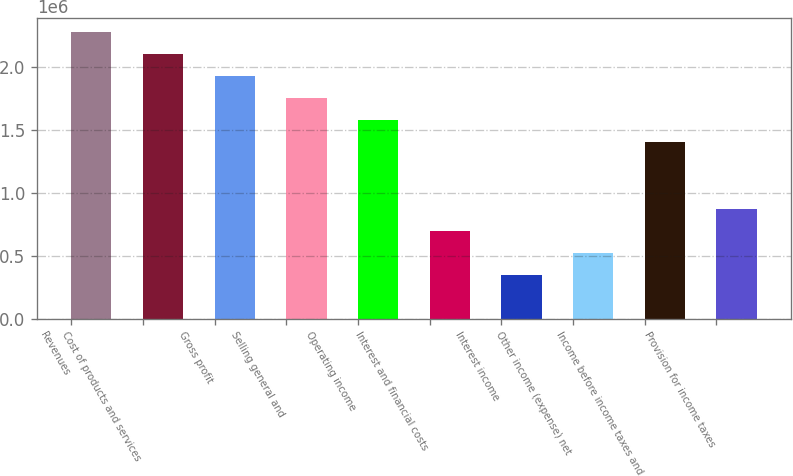<chart> <loc_0><loc_0><loc_500><loc_500><bar_chart><fcel>Revenues<fcel>Cost of products and services<fcel>Gross profit<fcel>Selling general and<fcel>Operating income<fcel>Interest and financial costs<fcel>Interest income<fcel>Other income (expense) net<fcel>Income before income taxes and<fcel>Provision for income taxes<nl><fcel>2.27169e+06<fcel>2.09695e+06<fcel>1.9222e+06<fcel>1.74745e+06<fcel>1.57271e+06<fcel>698983<fcel>349492<fcel>524237<fcel>1.39796e+06<fcel>873728<nl></chart> 